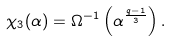Convert formula to latex. <formula><loc_0><loc_0><loc_500><loc_500>\chi _ { 3 } ( \alpha ) = \Omega ^ { - 1 } \left ( \alpha ^ { \frac { q - 1 } { 3 } } \right ) .</formula> 